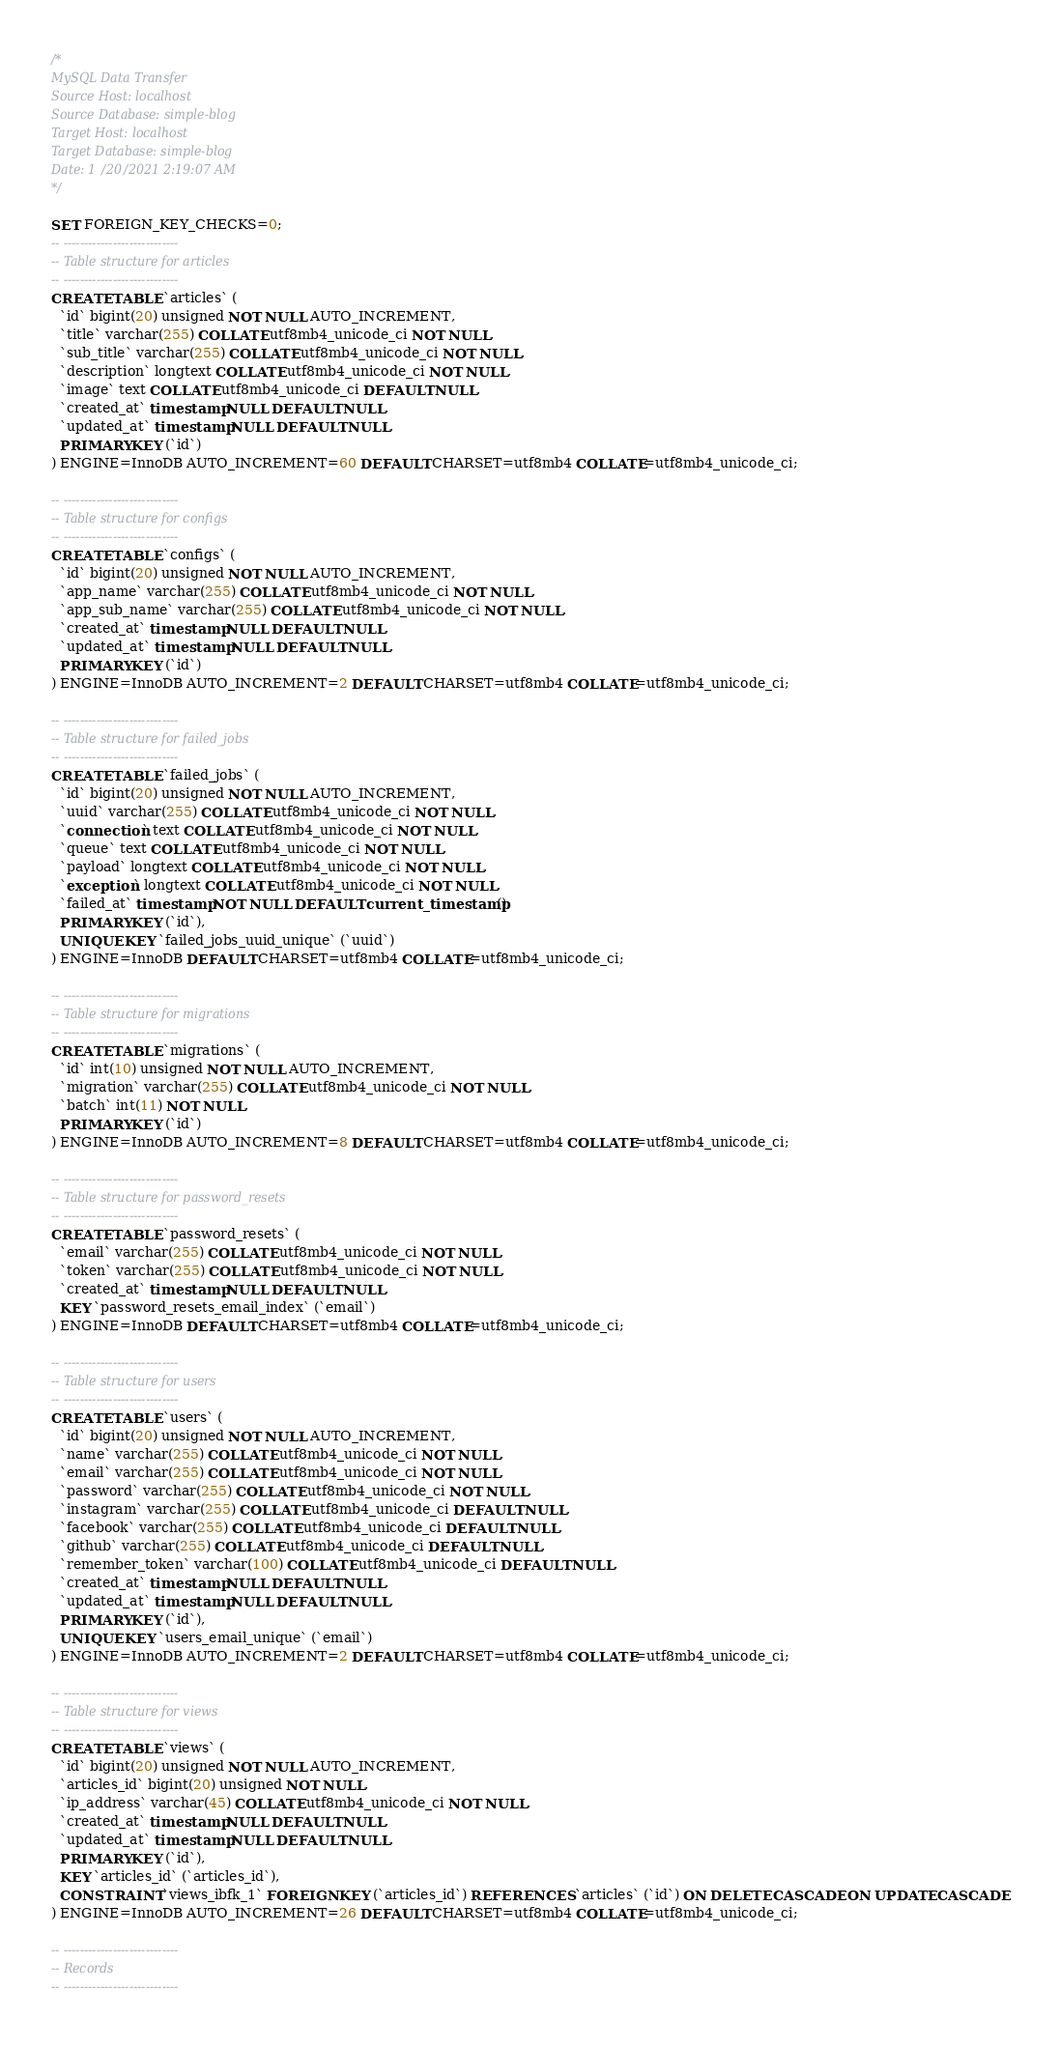<code> <loc_0><loc_0><loc_500><loc_500><_SQL_>/*
MySQL Data Transfer
Source Host: localhost
Source Database: simple-blog
Target Host: localhost
Target Database: simple-blog
Date: 1/20/2021 2:19:07 AM
*/

SET FOREIGN_KEY_CHECKS=0;
-- ----------------------------
-- Table structure for articles
-- ----------------------------
CREATE TABLE `articles` (
  `id` bigint(20) unsigned NOT NULL AUTO_INCREMENT,
  `title` varchar(255) COLLATE utf8mb4_unicode_ci NOT NULL,
  `sub_title` varchar(255) COLLATE utf8mb4_unicode_ci NOT NULL,
  `description` longtext COLLATE utf8mb4_unicode_ci NOT NULL,
  `image` text COLLATE utf8mb4_unicode_ci DEFAULT NULL,
  `created_at` timestamp NULL DEFAULT NULL,
  `updated_at` timestamp NULL DEFAULT NULL,
  PRIMARY KEY (`id`)
) ENGINE=InnoDB AUTO_INCREMENT=60 DEFAULT CHARSET=utf8mb4 COLLATE=utf8mb4_unicode_ci;

-- ----------------------------
-- Table structure for configs
-- ----------------------------
CREATE TABLE `configs` (
  `id` bigint(20) unsigned NOT NULL AUTO_INCREMENT,
  `app_name` varchar(255) COLLATE utf8mb4_unicode_ci NOT NULL,
  `app_sub_name` varchar(255) COLLATE utf8mb4_unicode_ci NOT NULL,
  `created_at` timestamp NULL DEFAULT NULL,
  `updated_at` timestamp NULL DEFAULT NULL,
  PRIMARY KEY (`id`)
) ENGINE=InnoDB AUTO_INCREMENT=2 DEFAULT CHARSET=utf8mb4 COLLATE=utf8mb4_unicode_ci;

-- ----------------------------
-- Table structure for failed_jobs
-- ----------------------------
CREATE TABLE `failed_jobs` (
  `id` bigint(20) unsigned NOT NULL AUTO_INCREMENT,
  `uuid` varchar(255) COLLATE utf8mb4_unicode_ci NOT NULL,
  `connection` text COLLATE utf8mb4_unicode_ci NOT NULL,
  `queue` text COLLATE utf8mb4_unicode_ci NOT NULL,
  `payload` longtext COLLATE utf8mb4_unicode_ci NOT NULL,
  `exception` longtext COLLATE utf8mb4_unicode_ci NOT NULL,
  `failed_at` timestamp NOT NULL DEFAULT current_timestamp(),
  PRIMARY KEY (`id`),
  UNIQUE KEY `failed_jobs_uuid_unique` (`uuid`)
) ENGINE=InnoDB DEFAULT CHARSET=utf8mb4 COLLATE=utf8mb4_unicode_ci;

-- ----------------------------
-- Table structure for migrations
-- ----------------------------
CREATE TABLE `migrations` (
  `id` int(10) unsigned NOT NULL AUTO_INCREMENT,
  `migration` varchar(255) COLLATE utf8mb4_unicode_ci NOT NULL,
  `batch` int(11) NOT NULL,
  PRIMARY KEY (`id`)
) ENGINE=InnoDB AUTO_INCREMENT=8 DEFAULT CHARSET=utf8mb4 COLLATE=utf8mb4_unicode_ci;

-- ----------------------------
-- Table structure for password_resets
-- ----------------------------
CREATE TABLE `password_resets` (
  `email` varchar(255) COLLATE utf8mb4_unicode_ci NOT NULL,
  `token` varchar(255) COLLATE utf8mb4_unicode_ci NOT NULL,
  `created_at` timestamp NULL DEFAULT NULL,
  KEY `password_resets_email_index` (`email`)
) ENGINE=InnoDB DEFAULT CHARSET=utf8mb4 COLLATE=utf8mb4_unicode_ci;

-- ----------------------------
-- Table structure for users
-- ----------------------------
CREATE TABLE `users` (
  `id` bigint(20) unsigned NOT NULL AUTO_INCREMENT,
  `name` varchar(255) COLLATE utf8mb4_unicode_ci NOT NULL,
  `email` varchar(255) COLLATE utf8mb4_unicode_ci NOT NULL,
  `password` varchar(255) COLLATE utf8mb4_unicode_ci NOT NULL,
  `instagram` varchar(255) COLLATE utf8mb4_unicode_ci DEFAULT NULL,
  `facebook` varchar(255) COLLATE utf8mb4_unicode_ci DEFAULT NULL,
  `github` varchar(255) COLLATE utf8mb4_unicode_ci DEFAULT NULL,
  `remember_token` varchar(100) COLLATE utf8mb4_unicode_ci DEFAULT NULL,
  `created_at` timestamp NULL DEFAULT NULL,
  `updated_at` timestamp NULL DEFAULT NULL,
  PRIMARY KEY (`id`),
  UNIQUE KEY `users_email_unique` (`email`)
) ENGINE=InnoDB AUTO_INCREMENT=2 DEFAULT CHARSET=utf8mb4 COLLATE=utf8mb4_unicode_ci;

-- ----------------------------
-- Table structure for views
-- ----------------------------
CREATE TABLE `views` (
  `id` bigint(20) unsigned NOT NULL AUTO_INCREMENT,
  `articles_id` bigint(20) unsigned NOT NULL,
  `ip_address` varchar(45) COLLATE utf8mb4_unicode_ci NOT NULL,
  `created_at` timestamp NULL DEFAULT NULL,
  `updated_at` timestamp NULL DEFAULT NULL,
  PRIMARY KEY (`id`),
  KEY `articles_id` (`articles_id`),
  CONSTRAINT `views_ibfk_1` FOREIGN KEY (`articles_id`) REFERENCES `articles` (`id`) ON DELETE CASCADE ON UPDATE CASCADE
) ENGINE=InnoDB AUTO_INCREMENT=26 DEFAULT CHARSET=utf8mb4 COLLATE=utf8mb4_unicode_ci;

-- ----------------------------
-- Records 
-- ----------------------------</code> 